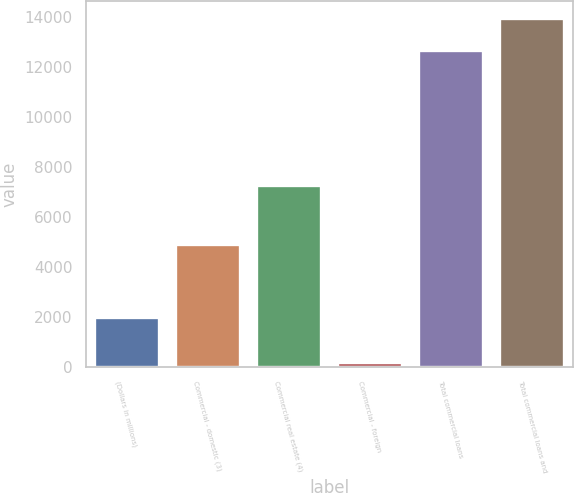Convert chart to OTSL. <chart><loc_0><loc_0><loc_500><loc_500><bar_chart><fcel>(Dollars in millions)<fcel>Commercial - domestic (3)<fcel>Commercial real estate (4)<fcel>Commercial - foreign<fcel>Total commercial loans<fcel>Total commercial loans and<nl><fcel>2009<fcel>4925<fcel>7286<fcel>177<fcel>12703<fcel>13957.1<nl></chart> 